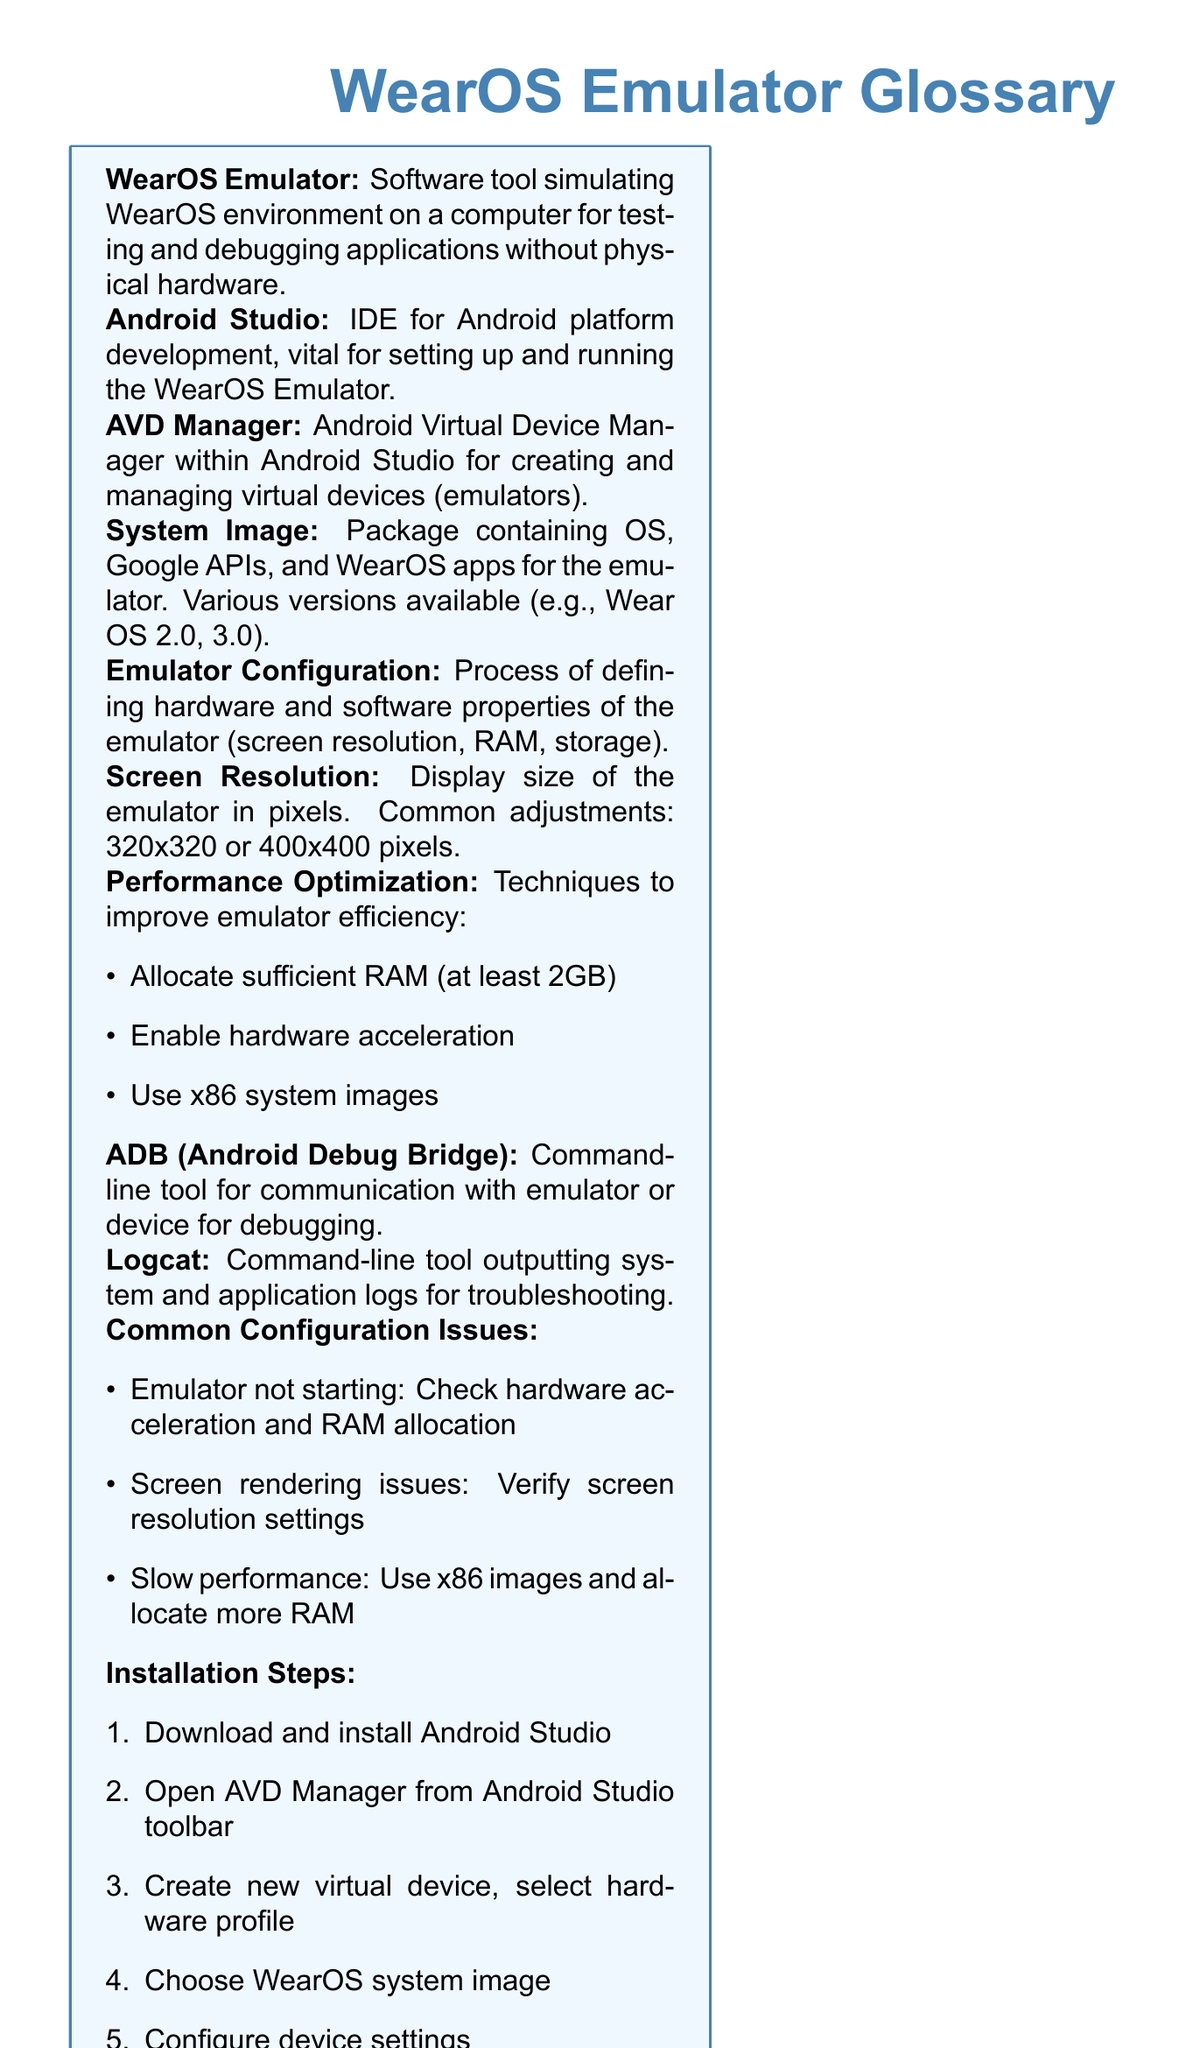What is the main purpose of the WearOS Emulator? The main purpose of the WearOS Emulator is to simulate the WearOS environment on a computer for testing and debugging applications without physical hardware.
Answer: Simulating WearOS environment What IDE is vital for setting up the WearOS Emulator? The IDE vital for setting up the WearOS Emulator is Android Studio.
Answer: Android Studio What does AVD stand for? AVD stands for Android Virtual Device.
Answer: Android Virtual Device What is the minimum RAM recommended for performance optimization? The minimum RAM recommended for performance optimization is at least 2GB.
Answer: 2GB What is a common screen resolution adjustment for the emulator? A common screen resolution adjustment for the emulator is 320x320 or 400x400 pixels.
Answer: 320x320 or 400x400 pixels What is the command-line tool for debugging called? The command-line tool for debugging is called ADB (Android Debug Bridge).
Answer: ADB Which devices can logs be outputted from? Logs can be outputted from the system and applications for troubleshooting.
Answer: System and applications What is one common configuration issue with the emulator? One common configuration issue is the emulator not starting, which may require checking hardware acceleration and RAM allocation.
Answer: Emulator not starting What is the first step in the installation process? The first step in the installation process is to download and install Android Studio.
Answer: Download and install Android Studio 